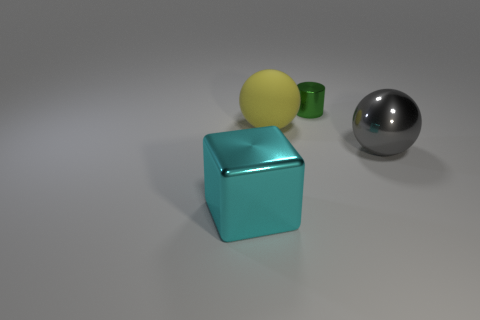Add 3 big yellow metallic cylinders. How many objects exist? 7 Subtract all blocks. How many objects are left? 3 Add 4 spheres. How many spheres exist? 6 Subtract 0 purple blocks. How many objects are left? 4 Subtract all large shiny spheres. Subtract all blue rubber balls. How many objects are left? 3 Add 2 gray spheres. How many gray spheres are left? 3 